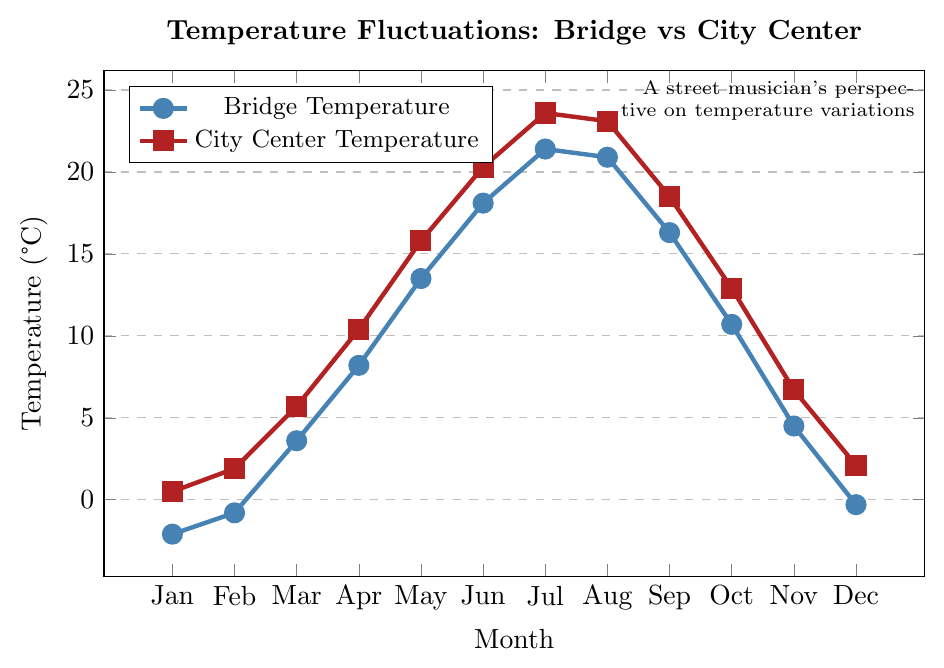What is the temperature difference between the bridge and the city center in July? To find the temperature difference, subtract the bridge temperature of July (21.4°C) from the city center temperature of July (23.6°C): 23.6 - 21.4 = 2.2°C.
Answer: 2.2°C Which month has the smallest temperature difference between the bridge and the city center? Calculate the absolute differences for each month and compare: January (2.6°C), February (2.7°C), March (2.1°C), April (2.2°C), May (2.3°C), June (2.2°C), July (2.2°C), August (2.2°C), September (2.2°C), October (2.2°C), November (2.2°C), and December (2.4°C).
Answer: March Are temperatures generally higher in the city center or under the bridge? Compare the temperatures month by month and see which location has consistently higher temperatures. In all months, the city center temperature is higher.
Answer: City center In which month is the temperature under the bridge closest to 10°C? Check the bridge temperatures for each month and see which is numerically closest to 10°C. The temperature in October is 10.7°C.
Answer: October What is the average temperature under the bridge in the spring months (March, April, May)? The temperatures for March, April, and May are 3.6°C, 8.2°C, and 13.5°C respectively. Sum them: 3.6 + 8.2 + 13.5 = 25.3. Then, divide by 3 to find the average: 25.3 / 3 ≈ 8.43°C.
Answer: 8.43°C During which month is the temperature under the bridge the highest? Scan the bridge temperatures and find the highest value. The highest temperature is 21.4°C in July.
Answer: July By how much does the temperature under the bridge increase from January to July? Find the temperature in January (-2.1°C) and July (21.4°C), then calculate the difference: 21.4 - (-2.1) = 23.5°C.
Answer: 23.5°C Which month shows the largest temperature difference between the bridge and the city center and what is that difference? Calculate the absolute differences for each month and identify the largest: January (2.6°C), February (2.7°C), March (2.1°C), April (2.2°C), May (2.3°C), June (2.2°C), July (2.2°C), August (2.2°C), September (2.2°C), October (2.2°C), November (2.2°C), and December (2.4°C). February has the largest difference: 2.7°C.
Answer: February, 2.7°C What is the general trend of temperatures from January to December for both locations? Observe the overall pattern of the temperatures plotted from January to December for both the bridge and the city center. Both temperatures increase from January to July and then decrease till December.
Answer: Increase then decrease How does the temperature trend under the bridge in November compare to the city center? Check the temperatures for November: Under the bridge (4.5°C), and in the city center (6.7°C). Both temperatures follow a similar decreasing trend from October.
Answer: Similar decreasing trend 